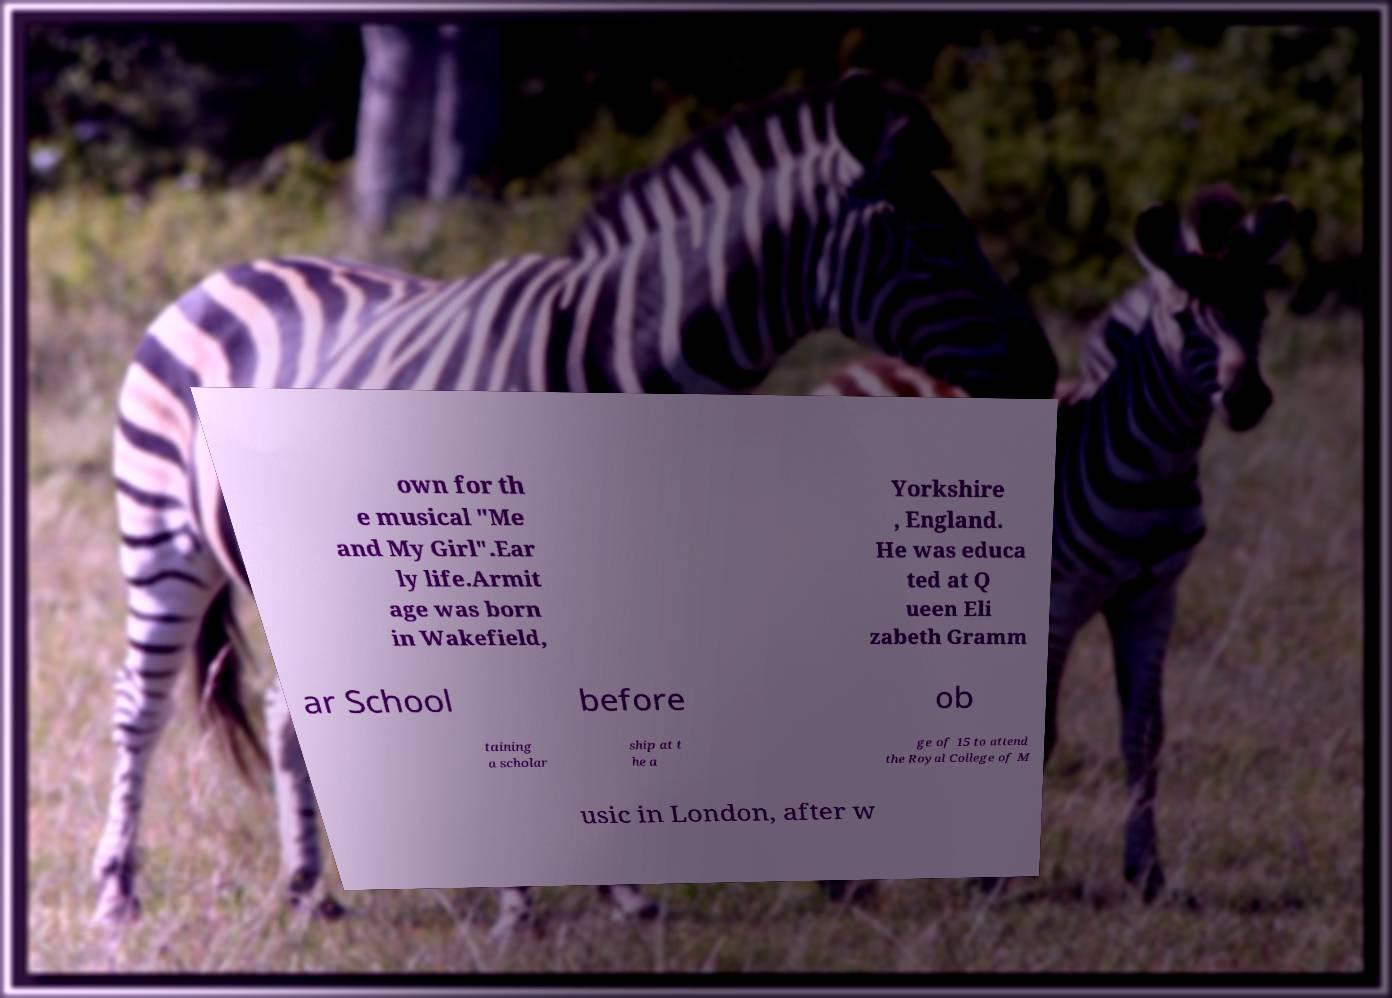What messages or text are displayed in this image? I need them in a readable, typed format. own for th e musical "Me and My Girl".Ear ly life.Armit age was born in Wakefield, Yorkshire , England. He was educa ted at Q ueen Eli zabeth Gramm ar School before ob taining a scholar ship at t he a ge of 15 to attend the Royal College of M usic in London, after w 